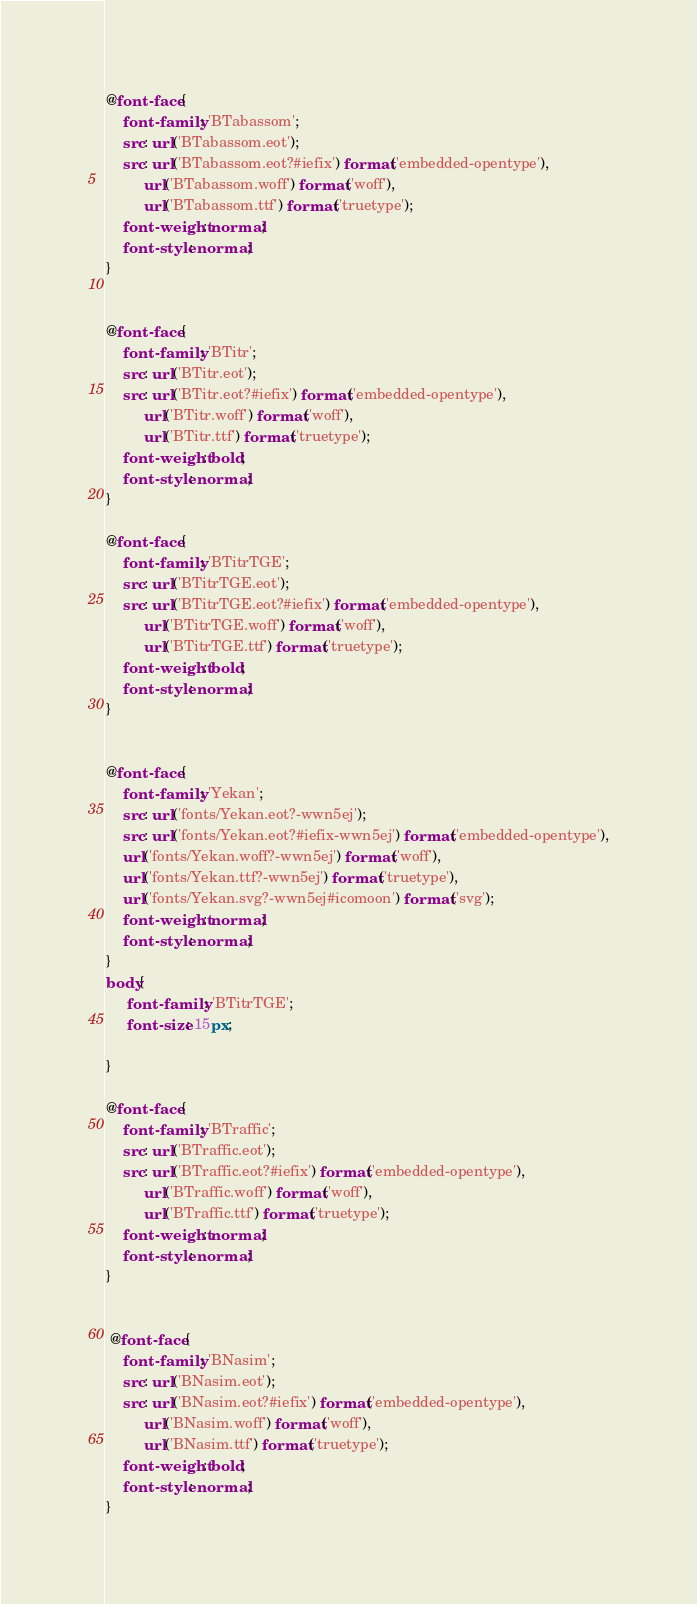Convert code to text. <code><loc_0><loc_0><loc_500><loc_500><_CSS_>@font-face {
    font-family: 'BTabassom';
    src: url('BTabassom.eot');
    src: url('BTabassom.eot?#iefix') format('embedded-opentype'),
         url('BTabassom.woff') format('woff'),
         url('BTabassom.ttf') format('truetype');
    font-weight: normal;
    font-style: normal;
}


@font-face {
    font-family: 'BTitr';
    src: url('BTitr.eot');
    src: url('BTitr.eot?#iefix') format('embedded-opentype'),
         url('BTitr.woff') format('woff'),
         url('BTitr.ttf') format('truetype');
    font-weight: bold;
    font-style: normal;
}

@font-face {
    font-family: 'BTitrTGE';
    src: url('BTitrTGE.eot');
    src: url('BTitrTGE.eot?#iefix') format('embedded-opentype'),
         url('BTitrTGE.woff') format('woff'), 
         url('BTitrTGE.ttf') format('truetype');
    font-weight: bold;
    font-style: normal;
}


@font-face {
	font-family: 'Yekan';
	src: url('fonts/Yekan.eot?-wwn5ej');
	src: url('fonts/Yekan.eot?#iefix-wwn5ej') format('embedded-opentype'),
	url('fonts/Yekan.woff?-wwn5ej') format('woff'),
	url('fonts/Yekan.ttf?-wwn5ej') format('truetype'),
	url('fonts/Yekan.svg?-wwn5ej#icomoon') format('svg');
	font-weight: normal;
	font-style: normal;
}
body{
	 font-family: 'BTitrTGE';
	 font-size: 15px;

}

@font-face {
    font-family: 'BTraffic';
    src: url('BTraffic.eot');
    src: url('BTraffic.eot?#iefix') format('embedded-opentype'),
         url('BTraffic.woff') format('woff'),
         url('BTraffic.ttf') format('truetype');
    font-weight: normal;
    font-style: normal;
}


 @font-face {
    font-family: 'BNasim';
    src: url('BNasim.eot');
    src: url('BNasim.eot?#iefix') format('embedded-opentype'),
         url('BNasim.woff') format('woff'),
         url('BNasim.ttf') format('truetype');
    font-weight: bold;
    font-style: normal;
}</code> 